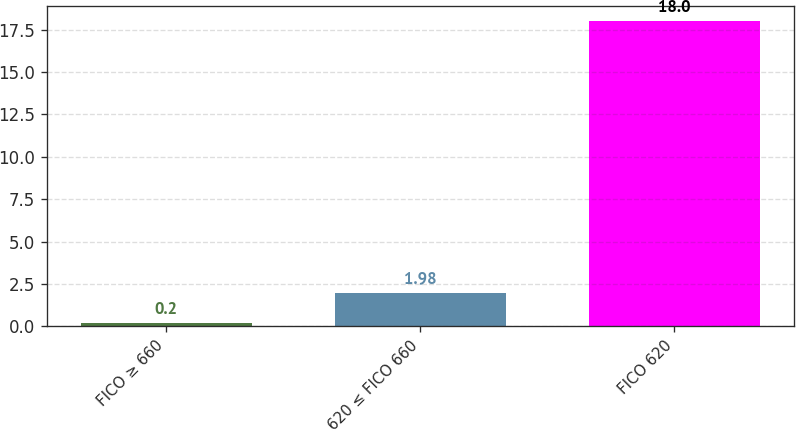<chart> <loc_0><loc_0><loc_500><loc_500><bar_chart><fcel>FICO ≥ 660<fcel>620 ≤ FICO 660<fcel>FICO 620<nl><fcel>0.2<fcel>1.98<fcel>18<nl></chart> 